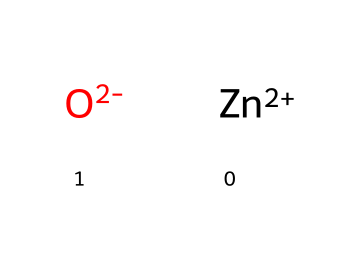How many atoms are in this chemical? This chemical includes one zinc ion and one oxide ion, for a total of two atoms.
Answer: two What charge does the zinc ion carry? The zinc ion is represented as [Zn+2], indicating it has a +2 charge.
Answer: +2 What is the charge of the oxide ion in this chemical? The oxide ion is represented as [O-2], indicating it has a -2 charge.
Answer: -2 What type of compound is represented by this chemical? The combination of a metal (zinc) and a non-metal (oxygen) suggests that this is an ionic compound.
Answer: ionic Which elements are present in this chemical? The chemical contains zinc and oxygen, which can be identified from the SMILES representation.
Answer: zinc, oxygen How might this zinc oxide influence marine life? Zinc oxide is known for its UV-blocking properties in sunscreens, indicating it may be a preferred ingredient for eco-friendly products.
Answer: eco-friendly 